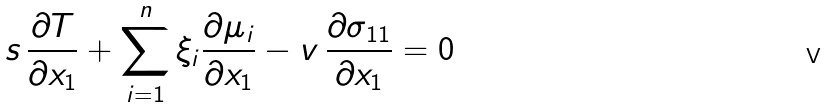<formula> <loc_0><loc_0><loc_500><loc_500>s \, \frac { \partial T } { \partial x _ { 1 } } + \sum _ { i = 1 } ^ { n } { \xi _ { i } \frac { \partial \mu _ { i } } { \partial x _ { 1 } } } - v \, \frac { \partial \sigma _ { 1 1 } } { \partial x _ { 1 } } = 0</formula> 